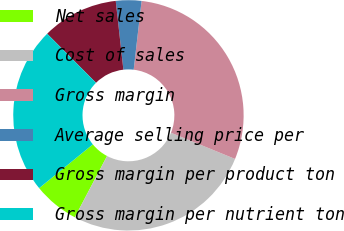<chart> <loc_0><loc_0><loc_500><loc_500><pie_chart><fcel>Net sales<fcel>Cost of sales<fcel>Gross margin<fcel>Average selling price per<fcel>Gross margin per product ton<fcel>Gross margin per nutrient ton<nl><fcel>6.41%<fcel>26.53%<fcel>29.36%<fcel>3.58%<fcel>10.71%<fcel>23.42%<nl></chart> 